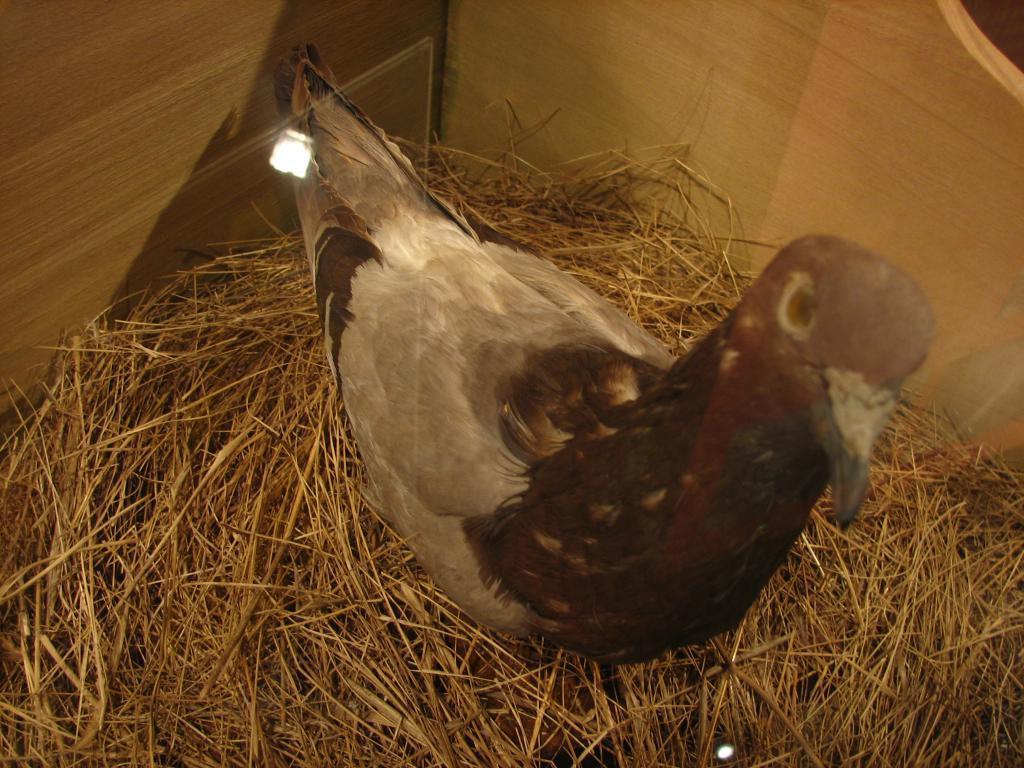How would you summarize this image in a sentence or two? In the center of the image there is pigeon. At the bottom of the image there is dry grass. In the background of the image there is wooden box. 